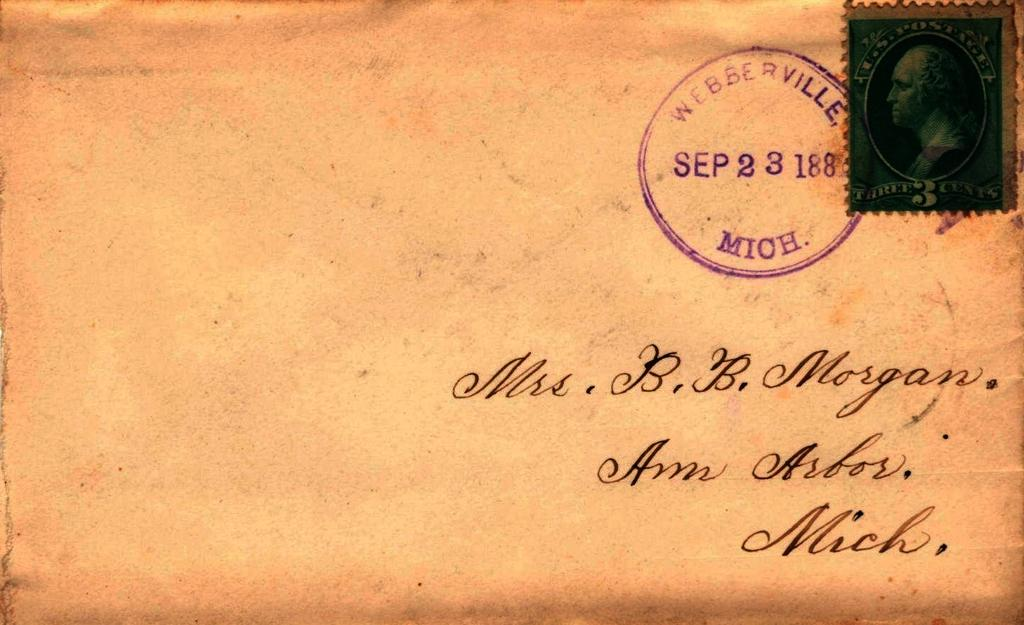<image>
Write a terse but informative summary of the picture. A letter from Sep 23 188 from Weberville, Mich was addressed to Mrs. B.B. Morgan 